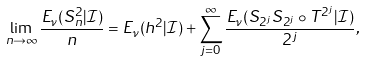<formula> <loc_0><loc_0><loc_500><loc_500>\lim _ { n \to \infty } \frac { E _ { \nu } ( S _ { n } ^ { 2 } | \mathcal { I } ) } { n } = E _ { \nu } ( h ^ { 2 } | \mathcal { I } ) + \sum _ { j = 0 } ^ { \infty } \frac { E _ { \nu } ( S _ { 2 ^ { j } } S _ { 2 ^ { j } } \circ T ^ { 2 ^ { j } } | \mathcal { I } ) } { 2 ^ { j } } ,</formula> 